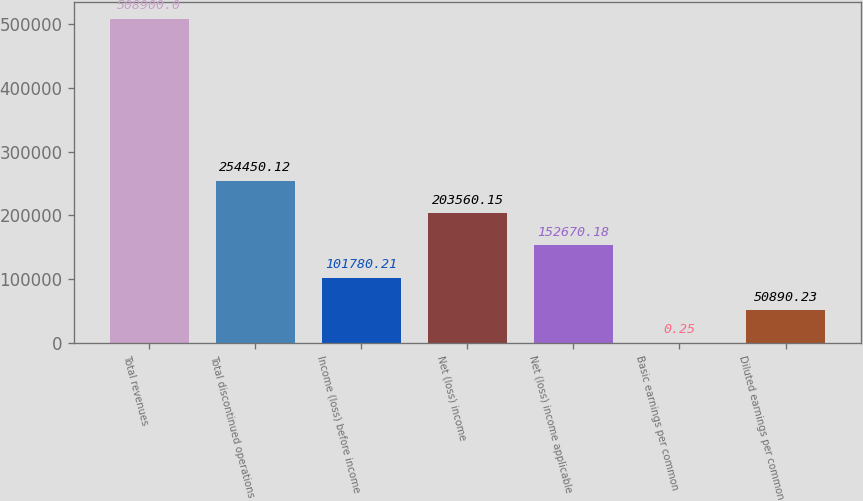Convert chart to OTSL. <chart><loc_0><loc_0><loc_500><loc_500><bar_chart><fcel>Total revenues<fcel>Total discontinued operations<fcel>Income (loss) before income<fcel>Net (loss) income<fcel>Net (loss) income applicable<fcel>Basic earnings per common<fcel>Diluted earnings per common<nl><fcel>508900<fcel>254450<fcel>101780<fcel>203560<fcel>152670<fcel>0.25<fcel>50890.2<nl></chart> 